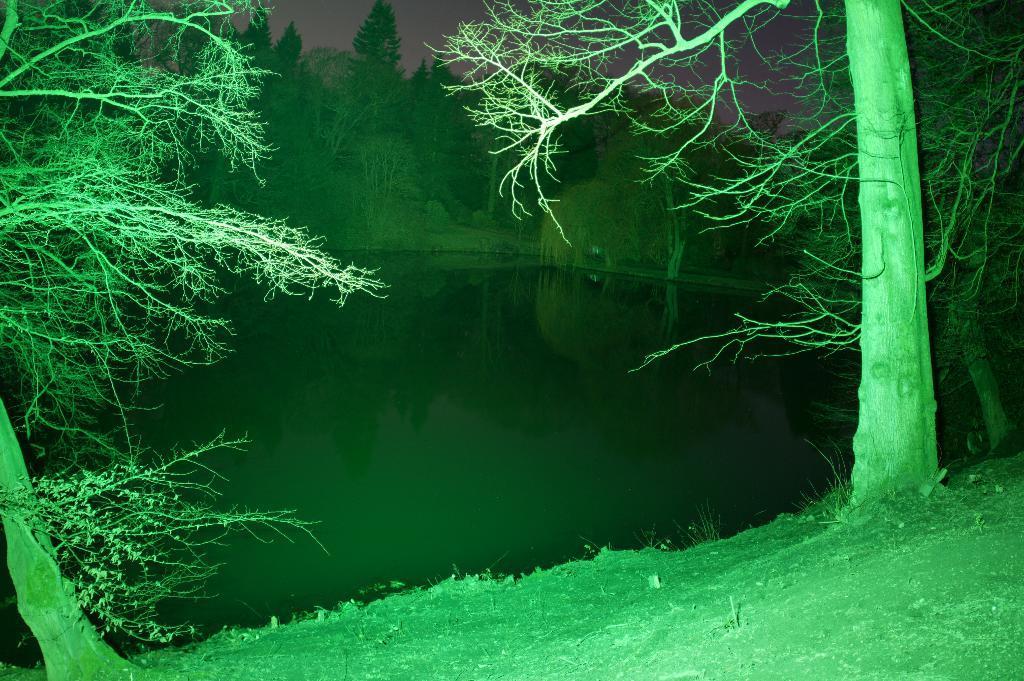How would you summarize this image in a sentence or two? In this image there is water. There is grass. There are trees in foreground and background. There is a sky. 